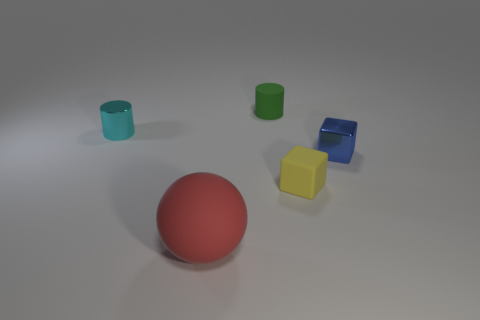Subtract all green cylinders. How many cylinders are left? 1 Add 5 tiny green cylinders. How many objects exist? 10 Subtract 1 cylinders. How many cylinders are left? 1 Subtract all blocks. How many objects are left? 3 Subtract all gray balls. Subtract all brown cylinders. How many balls are left? 1 Subtract all spheres. Subtract all big red rubber spheres. How many objects are left? 3 Add 1 matte spheres. How many matte spheres are left? 2 Add 5 tiny cylinders. How many tiny cylinders exist? 7 Subtract 0 purple balls. How many objects are left? 5 